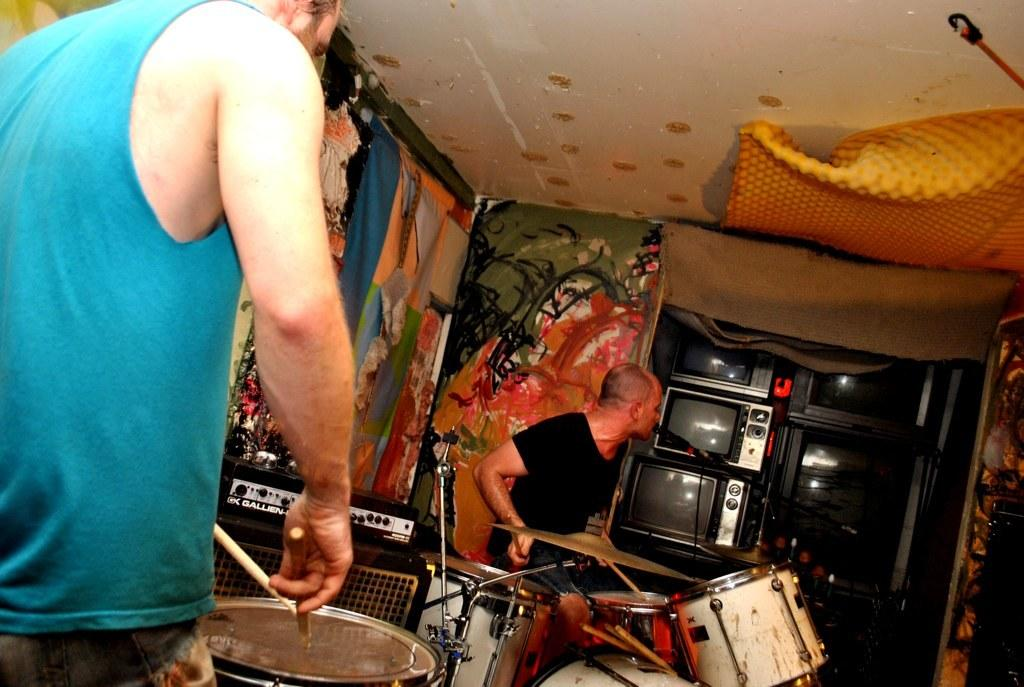What are the two guys in the image doing? The two guys in the image are playing drums. What is in front of the drummers? There is a microphone in front of the drummers. What other musical instruments can be seen in the image? There are other musical instruments present in the image. What electronic devices are visible in the image? There are televisions visible in the image. What type of laborer is working on the tree in the image? There is no laborer or tree present in the image; it features two guys playing drums and other musical instruments. What is the wire used for in the image? There is no wire present in the image. 